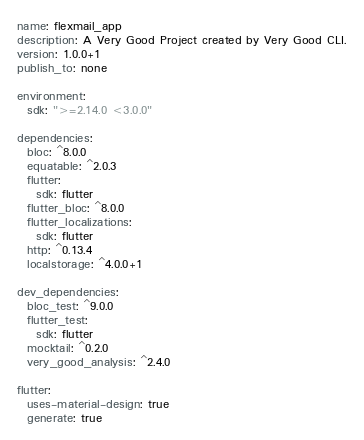Convert code to text. <code><loc_0><loc_0><loc_500><loc_500><_YAML_>name: flexmail_app
description: A Very Good Project created by Very Good CLI.
version: 1.0.0+1
publish_to: none

environment:
  sdk: ">=2.14.0 <3.0.0"

dependencies:
  bloc: ^8.0.0
  equatable: ^2.0.3
  flutter:
    sdk: flutter
  flutter_bloc: ^8.0.0
  flutter_localizations:
    sdk: flutter
  http: ^0.13.4
  localstorage: ^4.0.0+1

dev_dependencies:
  bloc_test: ^9.0.0
  flutter_test:
    sdk: flutter
  mocktail: ^0.2.0
  very_good_analysis: ^2.4.0

flutter:
  uses-material-design: true
  generate: true
</code> 